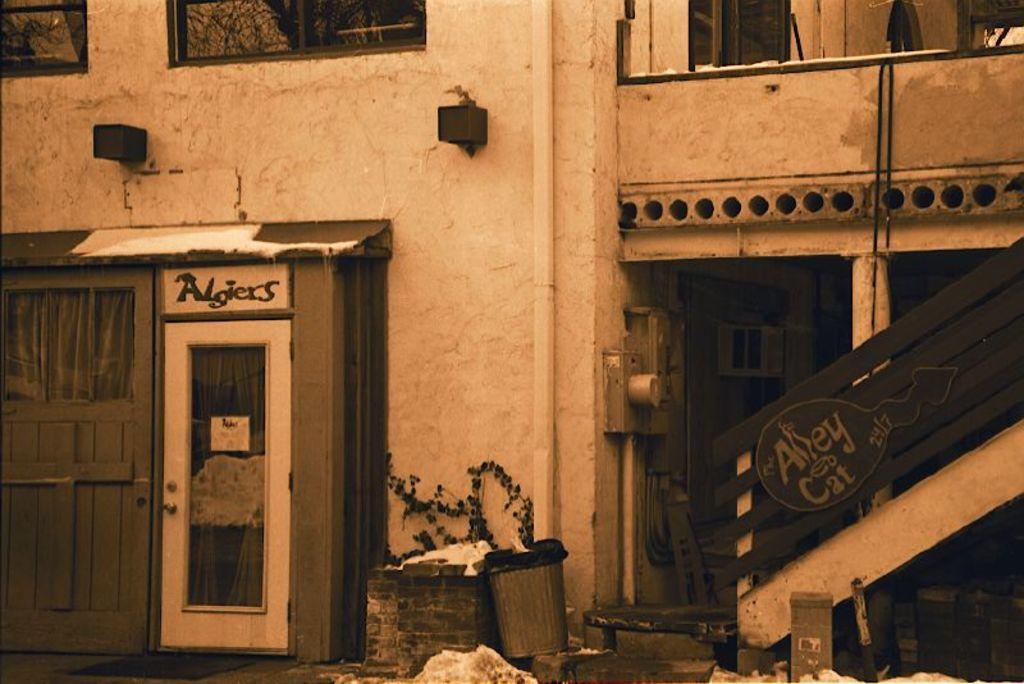Could you give a brief overview of what you see in this image? This is an edited image. In this picture we can see a building, windows, doors, pipe, rods, stairs, railing, boards, garbage bin, plant. At the bottom of the image we can see the floor. 